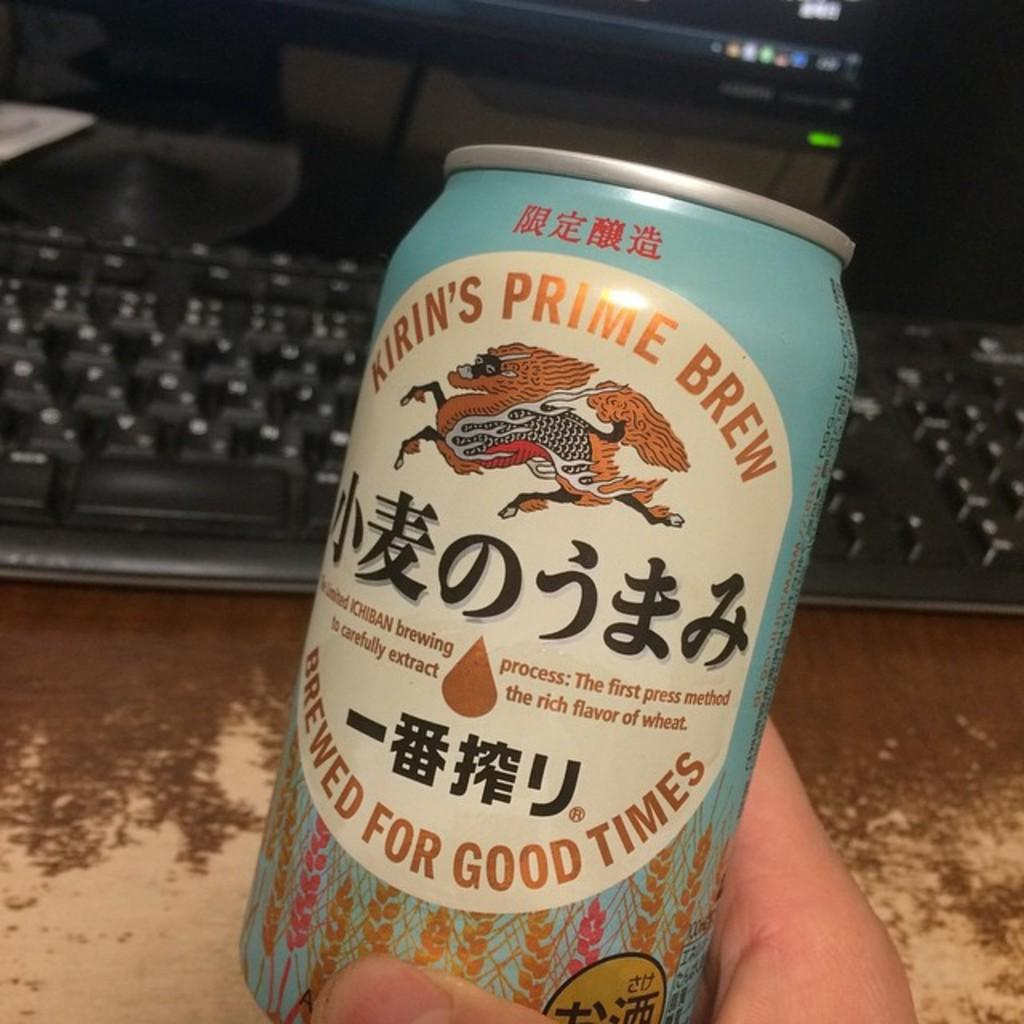<image>
Describe the image concisely. Someone is holding a can of Kirin's prime brew in front of a computer keyboard. 